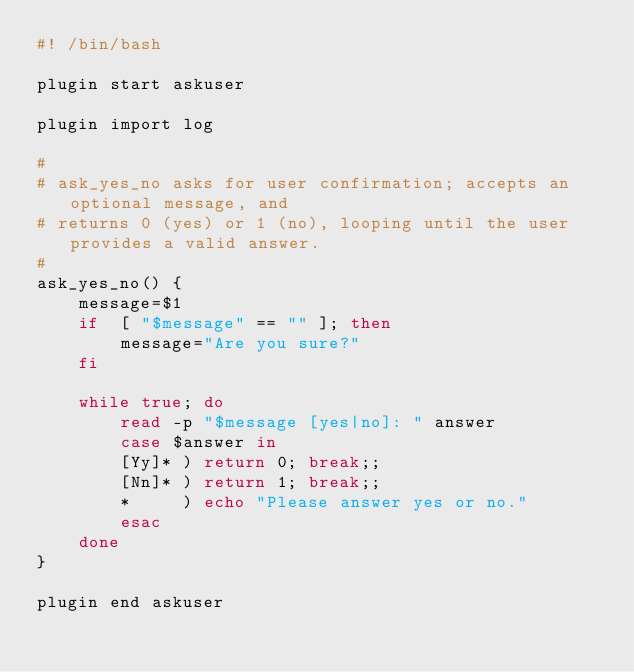<code> <loc_0><loc_0><loc_500><loc_500><_Bash_>#! /bin/bash

plugin start askuser

plugin import log

#
# ask_yes_no asks for user confirmation; accepts an optional message, and 
# returns 0 (yes) or 1 (no), looping until the user provides a valid answer.
#
ask_yes_no() {
    message=$1
    if  [ "$message" == "" ]; then
        message="Are you sure?"
    fi

    while true; do
        read -p "$message [yes|no]: " answer
        case $answer in
        [Yy]* ) return 0; break;;
        [Nn]* ) return 1; break;;
        *     ) echo "Please answer yes or no."
        esac
    done
}

plugin end askuser

</code> 